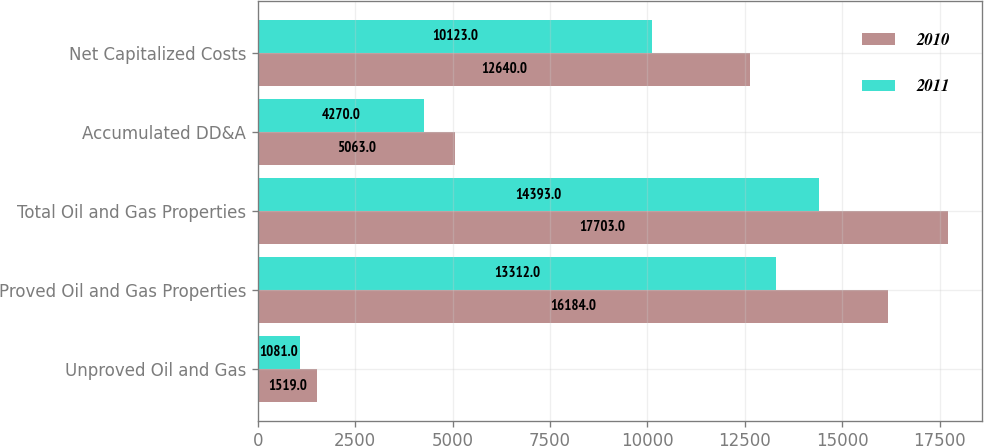Convert chart. <chart><loc_0><loc_0><loc_500><loc_500><stacked_bar_chart><ecel><fcel>Unproved Oil and Gas<fcel>Proved Oil and Gas Properties<fcel>Total Oil and Gas Properties<fcel>Accumulated DD&A<fcel>Net Capitalized Costs<nl><fcel>2010<fcel>1519<fcel>16184<fcel>17703<fcel>5063<fcel>12640<nl><fcel>2011<fcel>1081<fcel>13312<fcel>14393<fcel>4270<fcel>10123<nl></chart> 